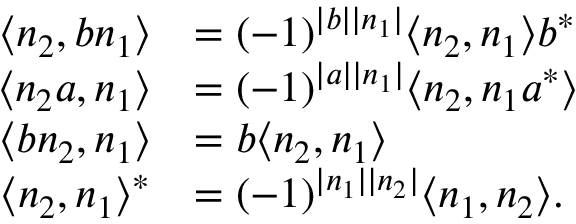<formula> <loc_0><loc_0><loc_500><loc_500>\begin{array} { r l } { \langle n _ { 2 } , b n _ { 1 } \rangle } & { = ( - 1 ) ^ { | b | | n _ { 1 } | } \langle n _ { 2 } , n _ { 1 } \rangle b ^ { * } } \\ { \langle n _ { 2 } a , n _ { 1 } \rangle } & { = ( - 1 ) ^ { | a | | n _ { 1 } | } \langle n _ { 2 } , n _ { 1 } a ^ { * } \rangle } \\ { \langle b n _ { 2 } , n _ { 1 } \rangle } & { = b \langle n _ { 2 } , n _ { 1 } \rangle } \\ { \langle n _ { 2 } , n _ { 1 } \rangle ^ { * } } & { = ( - 1 ) ^ { | n _ { 1 } | | n _ { 2 } | } \langle n _ { 1 } , n _ { 2 } \rangle . } \end{array}</formula> 